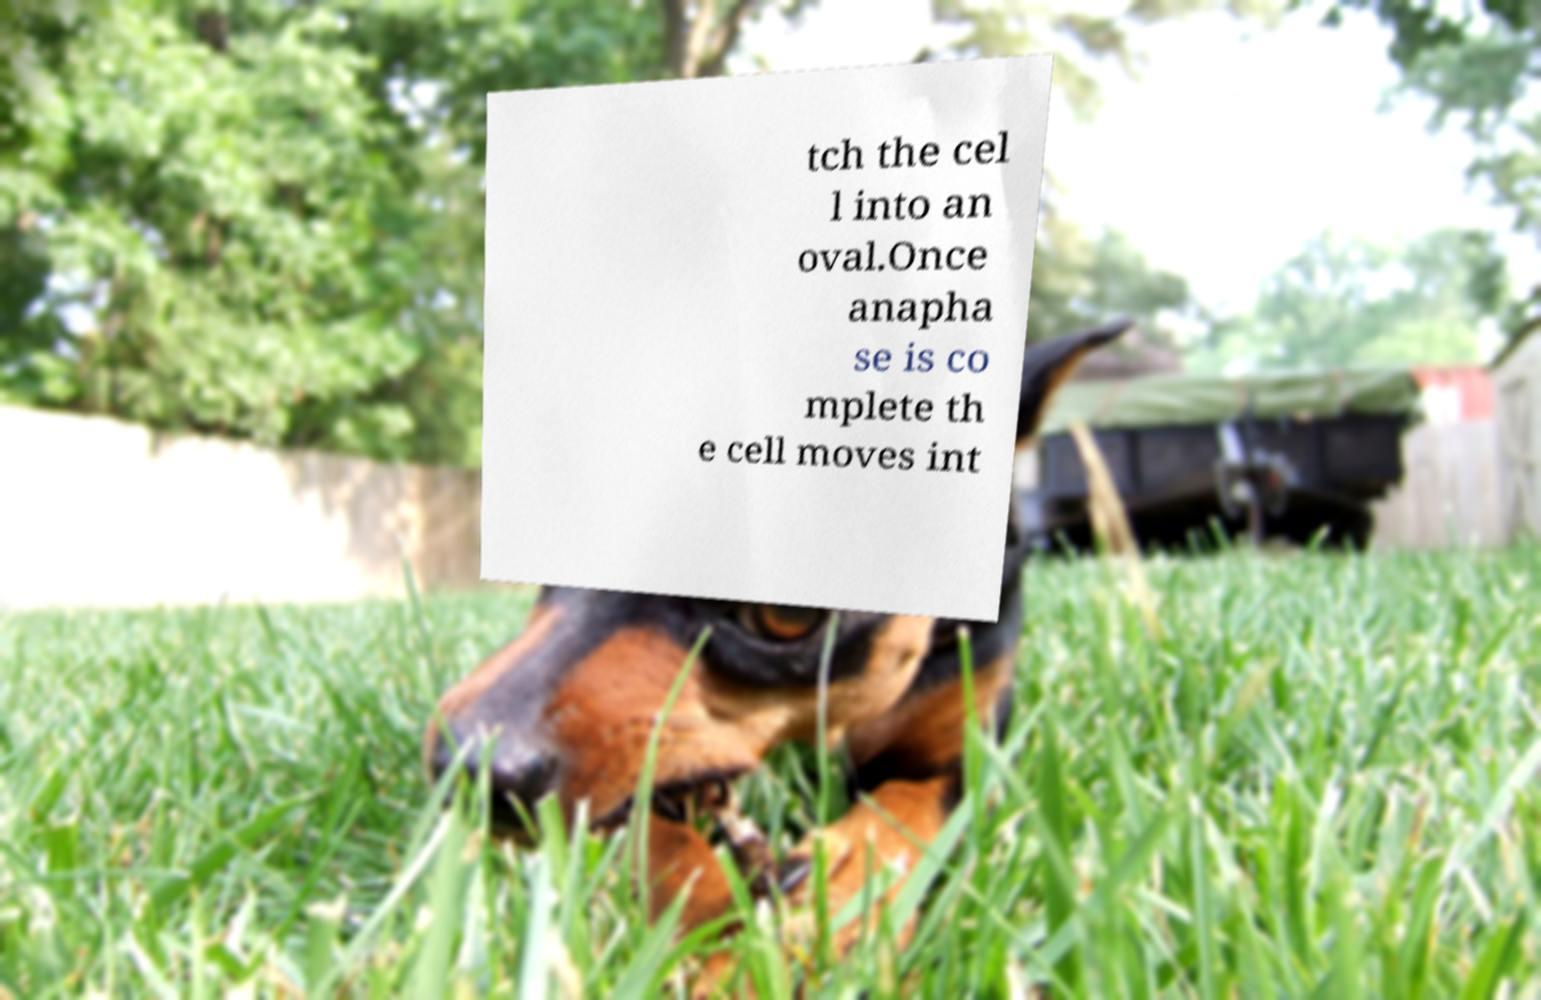Could you extract and type out the text from this image? tch the cel l into an oval.Once anapha se is co mplete th e cell moves int 